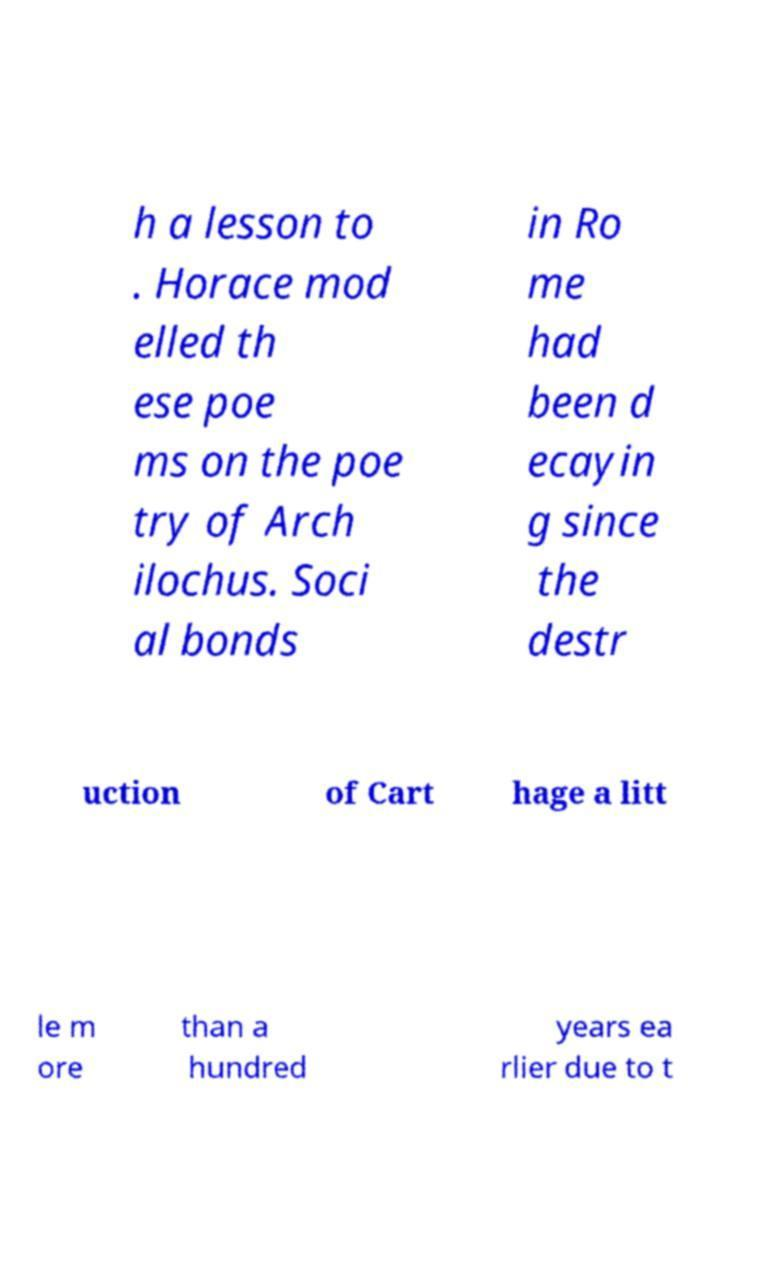Could you assist in decoding the text presented in this image and type it out clearly? h a lesson to . Horace mod elled th ese poe ms on the poe try of Arch ilochus. Soci al bonds in Ro me had been d ecayin g since the destr uction of Cart hage a litt le m ore than a hundred years ea rlier due to t 